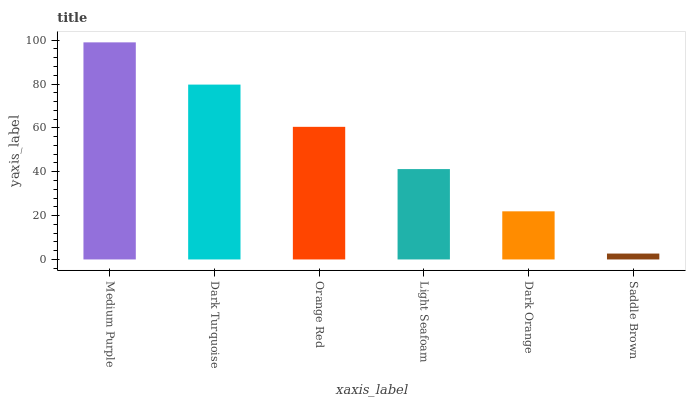Is Saddle Brown the minimum?
Answer yes or no. Yes. Is Medium Purple the maximum?
Answer yes or no. Yes. Is Dark Turquoise the minimum?
Answer yes or no. No. Is Dark Turquoise the maximum?
Answer yes or no. No. Is Medium Purple greater than Dark Turquoise?
Answer yes or no. Yes. Is Dark Turquoise less than Medium Purple?
Answer yes or no. Yes. Is Dark Turquoise greater than Medium Purple?
Answer yes or no. No. Is Medium Purple less than Dark Turquoise?
Answer yes or no. No. Is Orange Red the high median?
Answer yes or no. Yes. Is Light Seafoam the low median?
Answer yes or no. Yes. Is Saddle Brown the high median?
Answer yes or no. No. Is Dark Orange the low median?
Answer yes or no. No. 